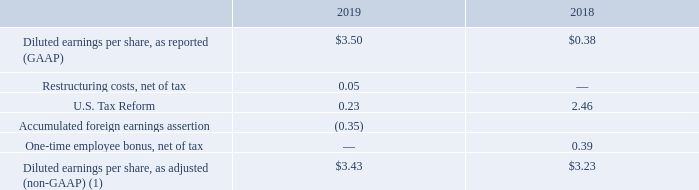Diluted earnings per share. Diluted earnings per share for fiscal 2019 and 2018, as well as information as to the effects of special events that occurred in the indicated periods, as previously discussed and detailed below, were as follows (dollars in millions):
(1) We believe the non-GAAP presentation of diluted earnings per share excluding special tax items, consisting of those related to Tax Reform and a change in our permanent reinvestment assertions related to undistributed earnings of two foreign subsidiaries, as well as restructuring costs and the one-time employee bonus, provide additional insight over the change from the comparative reporting periods by eliminating the effects of special or unusual items. In addition, the Company believes that its diluted earnings per share, as adjusted, enhances the ability of investors to analyze the Company’s operating performance and supplements, but does not replace, its diluted earnings per share calculated in accordance with U.S. GAAP.
Diluted earnings per share increased to $3.50 in fiscal 2019 from $0.38 in fiscal 2018 primarily as a result of increased net income due to the factors discussed above and a reduction in diluted shares outstanding due to repurchase activity under the Company's stock repurchase plans.
Which years does the table provide information for diluted earnings per share? 2019, 2018. What was the diluted earnings per share in 2019? 3.50. What was the amount of U.S. Tax Reform in 2019?
Answer scale should be: million. 0.23. Which years did Diluted earnings per share, as adjusted (non-GAAP) exceed $3 million? (2019:3.43),(2018:3.23)
Answer: 2019, 2018. What was the change in the amount of U.S Tax Reform between 2018 and 2019?
Answer scale should be: million. 0.23-2.46
Answer: -2.23. What was the percentage change in diluted earnings per share between 2018 and 2019?
Answer scale should be: percent. (3.50-0.38)/0.38
Answer: 821.05. 